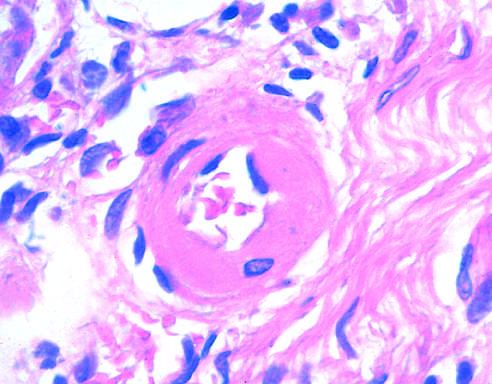what is thickened with the deposition of amorphous proteinaceous material (hyalinized)?
Answer the question using a single word or phrase. The arteriolar wall 